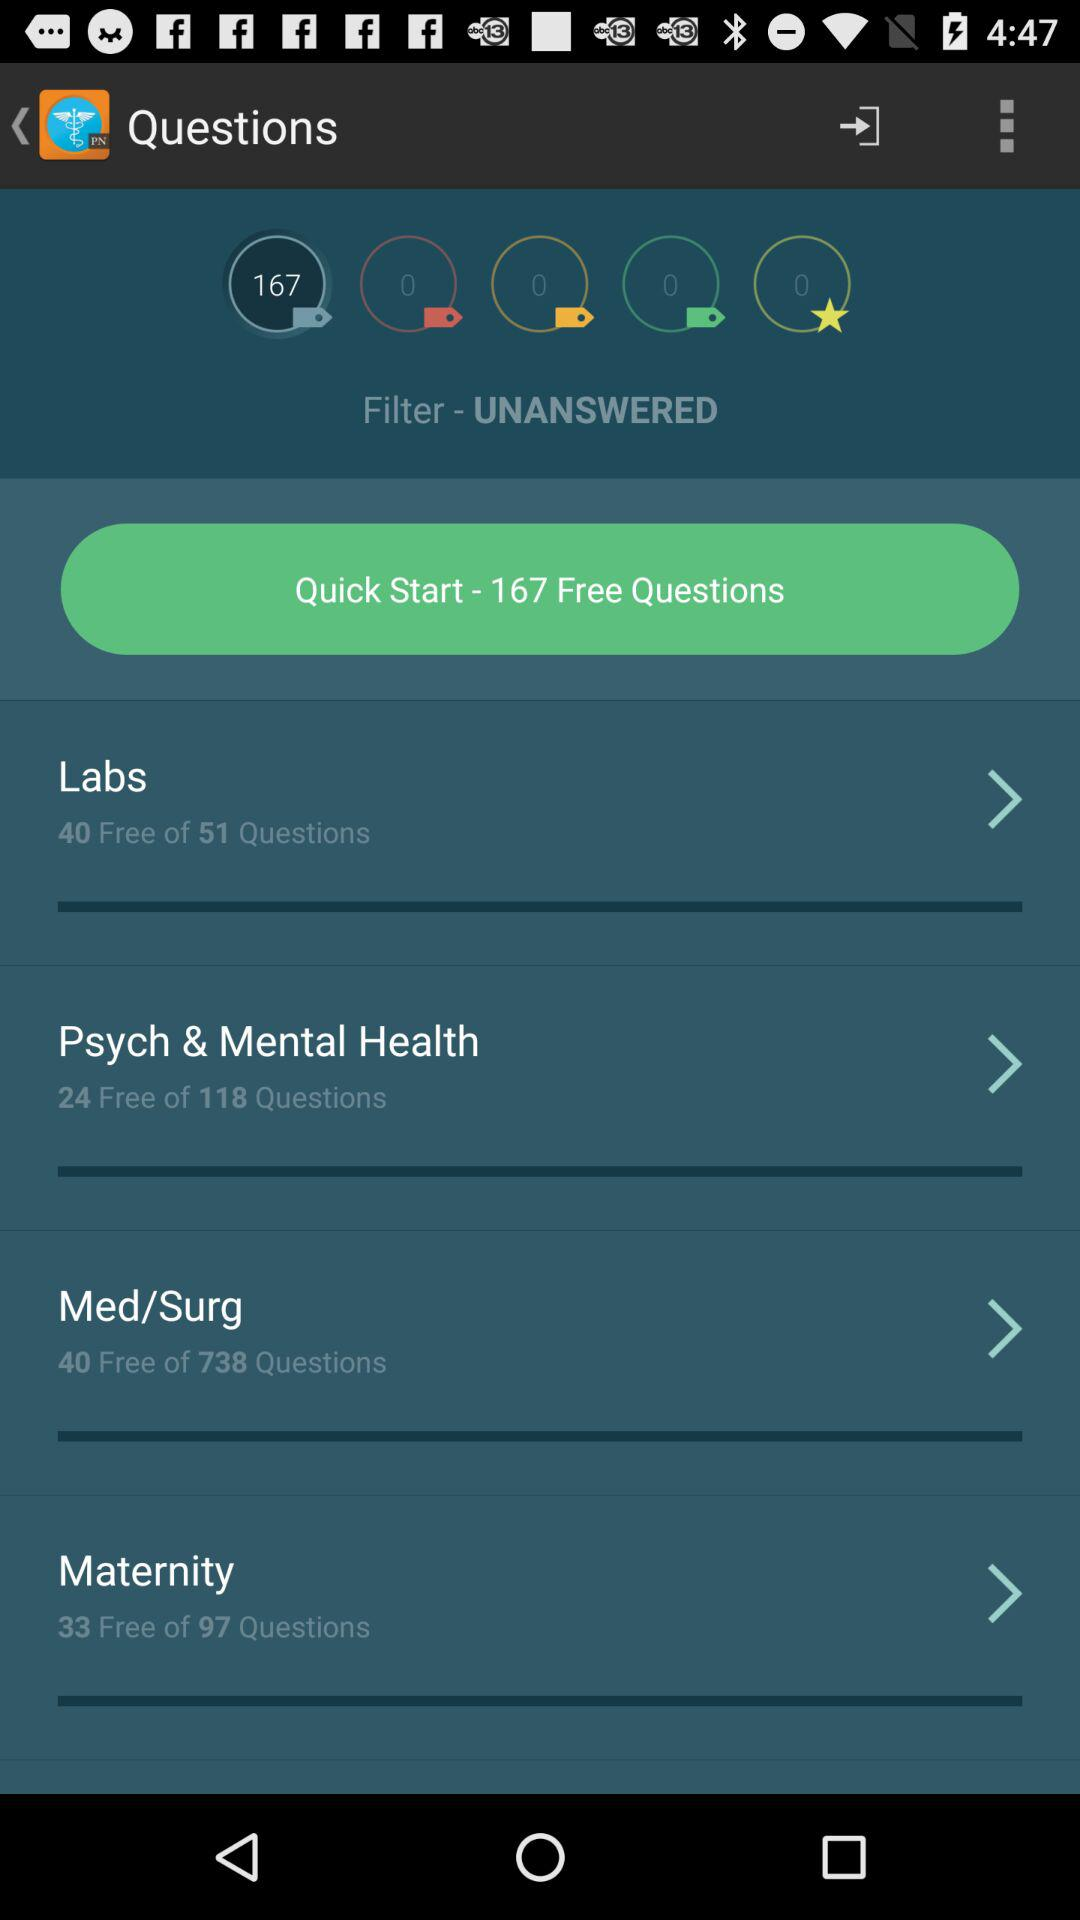How many questions are there in the medical/surgery course? There are 738 questions in the medical/surgery course. 